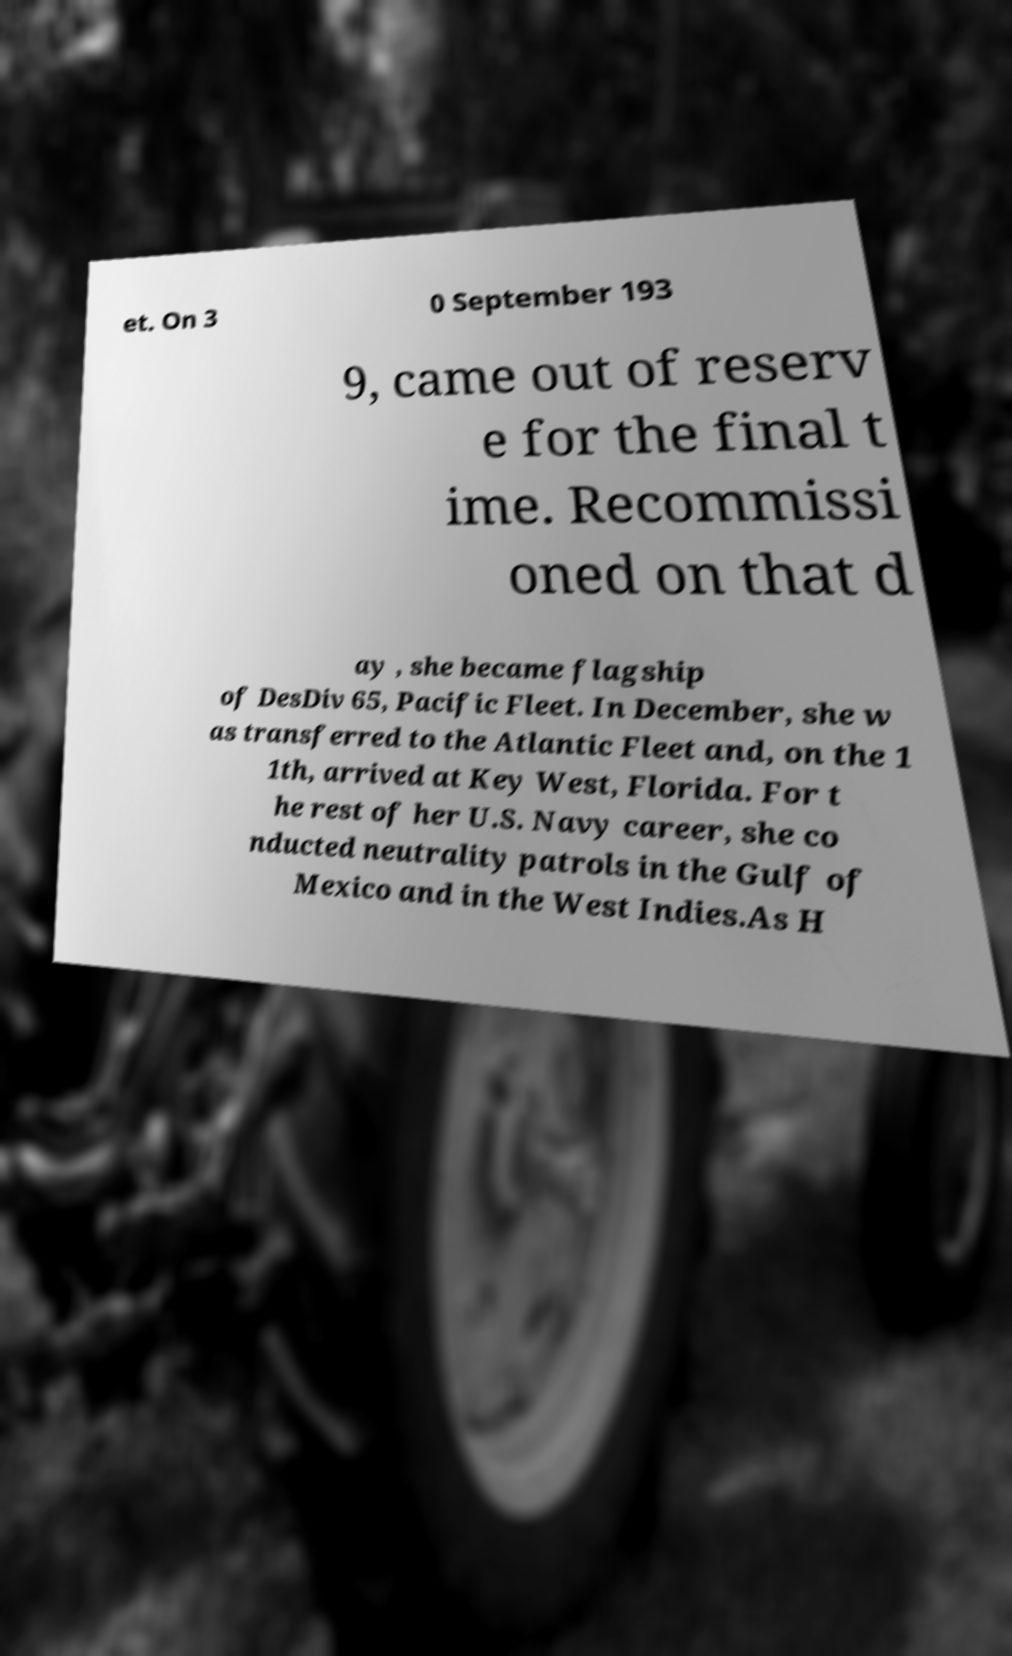Can you accurately transcribe the text from the provided image for me? et. On 3 0 September 193 9, came out of reserv e for the final t ime. Recommissi oned on that d ay , she became flagship of DesDiv 65, Pacific Fleet. In December, she w as transferred to the Atlantic Fleet and, on the 1 1th, arrived at Key West, Florida. For t he rest of her U.S. Navy career, she co nducted neutrality patrols in the Gulf of Mexico and in the West Indies.As H 